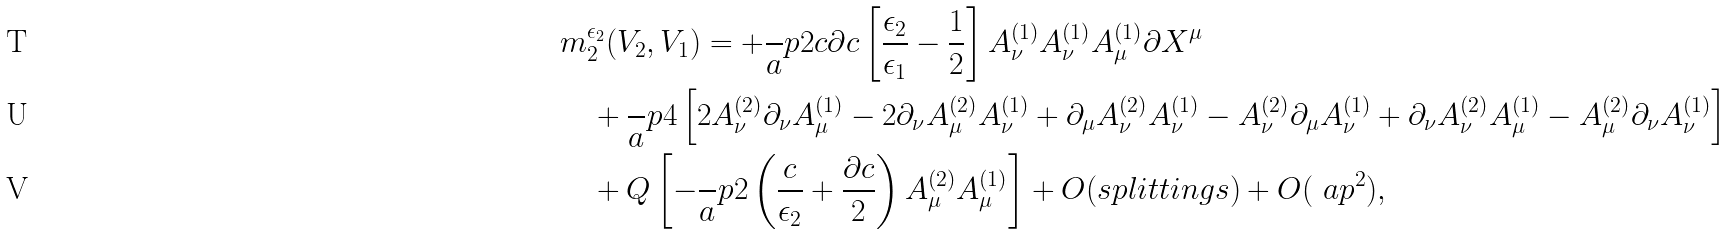Convert formula to latex. <formula><loc_0><loc_0><loc_500><loc_500>& m _ { 2 } ^ { \epsilon _ { 2 } } ( V _ { 2 } , V _ { 1 } ) = + \frac { \ } { a } p 2 c \partial c \left [ \frac { \epsilon _ { 2 } } { \epsilon _ { 1 } } - \frac { 1 } { 2 } \right ] A _ { \nu } ^ { ( 1 ) } A _ { \nu } ^ { ( 1 ) } A _ { \mu } ^ { ( 1 ) } \partial X ^ { \mu } \\ & \quad + \frac { \ } { a } p 4 \left [ 2 A _ { \nu } ^ { ( 2 ) } \partial _ { \nu } A _ { \mu } ^ { ( 1 ) } - 2 \partial _ { \nu } A _ { \mu } ^ { ( 2 ) } A _ { \nu } ^ { ( 1 ) } + \partial _ { \mu } A _ { \nu } ^ { ( 2 ) } A _ { \nu } ^ { ( 1 ) } - A _ { \nu } ^ { ( 2 ) } \partial _ { \mu } A _ { \nu } ^ { ( 1 ) } + \partial _ { \nu } A _ { \nu } ^ { ( 2 ) } A _ { \mu } ^ { ( 1 ) } - A _ { \mu } ^ { ( 2 ) } \partial _ { \nu } A _ { \nu } ^ { ( 1 ) } \right ] \\ & \quad + Q \left [ - \frac { \ } { a } p 2 \left ( \frac { c } { \epsilon _ { 2 } } + \frac { \partial c } 2 \right ) A _ { \mu } ^ { ( 2 ) } A _ { \mu } ^ { ( 1 ) } \right ] + O ( s p l i t t i n g s ) + O ( \ a p ^ { 2 } ) ,</formula> 